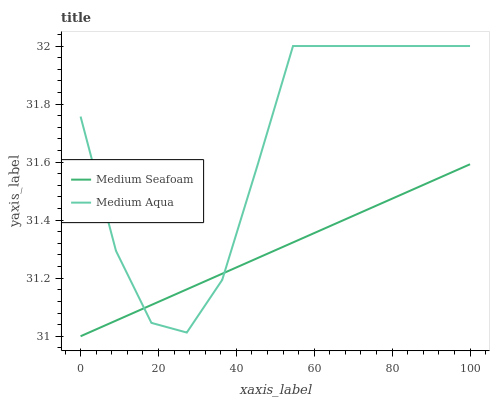Does Medium Seafoam have the minimum area under the curve?
Answer yes or no. Yes. Does Medium Aqua have the maximum area under the curve?
Answer yes or no. Yes. Does Medium Seafoam have the maximum area under the curve?
Answer yes or no. No. Is Medium Seafoam the smoothest?
Answer yes or no. Yes. Is Medium Aqua the roughest?
Answer yes or no. Yes. Is Medium Seafoam the roughest?
Answer yes or no. No. Does Medium Seafoam have the lowest value?
Answer yes or no. Yes. Does Medium Aqua have the highest value?
Answer yes or no. Yes. Does Medium Seafoam have the highest value?
Answer yes or no. No. Does Medium Seafoam intersect Medium Aqua?
Answer yes or no. Yes. Is Medium Seafoam less than Medium Aqua?
Answer yes or no. No. Is Medium Seafoam greater than Medium Aqua?
Answer yes or no. No. 